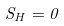Convert formula to latex. <formula><loc_0><loc_0><loc_500><loc_500>S _ { H } = 0</formula> 